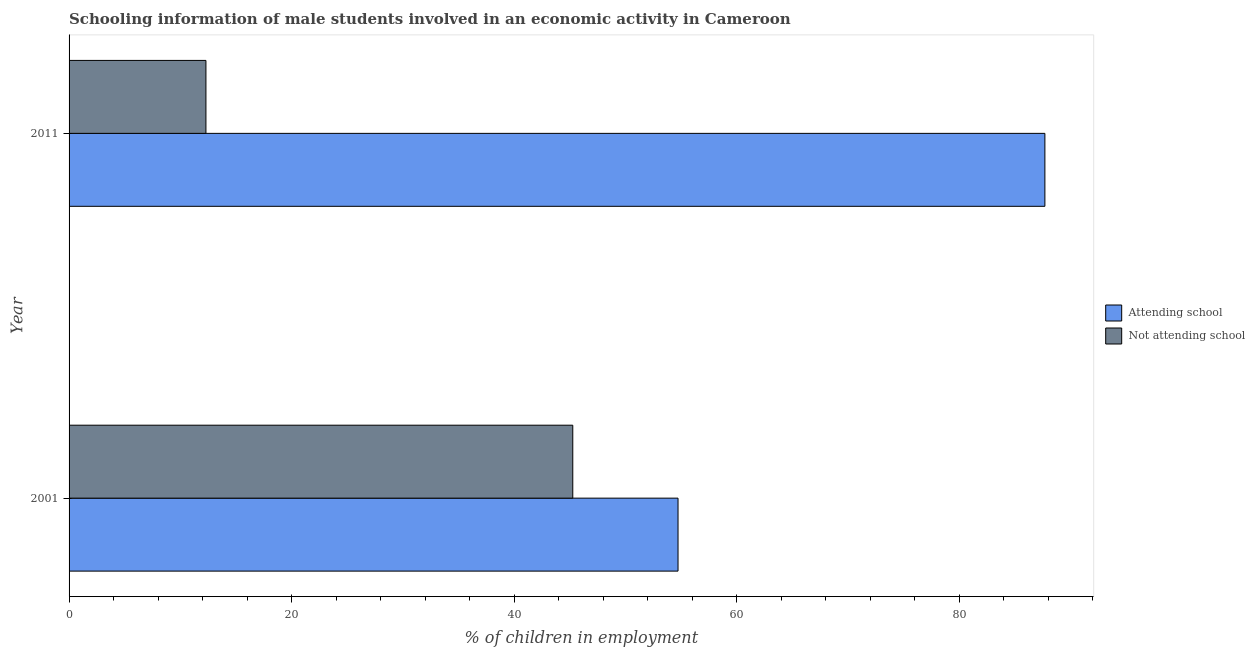How many different coloured bars are there?
Offer a very short reply. 2. Are the number of bars per tick equal to the number of legend labels?
Ensure brevity in your answer.  Yes. How many bars are there on the 1st tick from the top?
Your answer should be compact. 2. How many bars are there on the 2nd tick from the bottom?
Offer a very short reply. 2. What is the label of the 2nd group of bars from the top?
Your answer should be compact. 2001. Across all years, what is the maximum percentage of employed males who are not attending school?
Your answer should be very brief. 45.27. Across all years, what is the minimum percentage of employed males who are not attending school?
Offer a terse response. 12.3. In which year was the percentage of employed males who are attending school maximum?
Provide a short and direct response. 2011. What is the total percentage of employed males who are attending school in the graph?
Offer a terse response. 142.43. What is the difference between the percentage of employed males who are not attending school in 2001 and that in 2011?
Give a very brief answer. 32.97. What is the difference between the percentage of employed males who are attending school in 2011 and the percentage of employed males who are not attending school in 2001?
Give a very brief answer. 42.43. What is the average percentage of employed males who are not attending school per year?
Keep it short and to the point. 28.79. In the year 2001, what is the difference between the percentage of employed males who are not attending school and percentage of employed males who are attending school?
Your answer should be very brief. -9.46. What is the ratio of the percentage of employed males who are not attending school in 2001 to that in 2011?
Give a very brief answer. 3.68. Is the percentage of employed males who are attending school in 2001 less than that in 2011?
Your answer should be very brief. Yes. What does the 1st bar from the top in 2001 represents?
Offer a terse response. Not attending school. What does the 1st bar from the bottom in 2011 represents?
Your answer should be compact. Attending school. How many bars are there?
Offer a terse response. 4. Are all the bars in the graph horizontal?
Your answer should be very brief. Yes. How many years are there in the graph?
Your answer should be compact. 2. Does the graph contain any zero values?
Provide a succinct answer. No. How are the legend labels stacked?
Keep it short and to the point. Vertical. What is the title of the graph?
Provide a succinct answer. Schooling information of male students involved in an economic activity in Cameroon. What is the label or title of the X-axis?
Make the answer very short. % of children in employment. What is the % of children in employment in Attending school in 2001?
Keep it short and to the point. 54.73. What is the % of children in employment in Not attending school in 2001?
Make the answer very short. 45.27. What is the % of children in employment in Attending school in 2011?
Make the answer very short. 87.7. Across all years, what is the maximum % of children in employment in Attending school?
Ensure brevity in your answer.  87.7. Across all years, what is the maximum % of children in employment of Not attending school?
Your answer should be compact. 45.27. Across all years, what is the minimum % of children in employment of Attending school?
Your answer should be compact. 54.73. What is the total % of children in employment in Attending school in the graph?
Offer a terse response. 142.43. What is the total % of children in employment of Not attending school in the graph?
Make the answer very short. 57.57. What is the difference between the % of children in employment in Attending school in 2001 and that in 2011?
Offer a terse response. -32.97. What is the difference between the % of children in employment in Not attending school in 2001 and that in 2011?
Your answer should be compact. 32.97. What is the difference between the % of children in employment of Attending school in 2001 and the % of children in employment of Not attending school in 2011?
Ensure brevity in your answer.  42.43. What is the average % of children in employment in Attending school per year?
Keep it short and to the point. 71.21. What is the average % of children in employment in Not attending school per year?
Make the answer very short. 28.79. In the year 2001, what is the difference between the % of children in employment in Attending school and % of children in employment in Not attending school?
Your answer should be compact. 9.46. In the year 2011, what is the difference between the % of children in employment in Attending school and % of children in employment in Not attending school?
Provide a succinct answer. 75.4. What is the ratio of the % of children in employment of Attending school in 2001 to that in 2011?
Keep it short and to the point. 0.62. What is the ratio of the % of children in employment in Not attending school in 2001 to that in 2011?
Make the answer very short. 3.68. What is the difference between the highest and the second highest % of children in employment in Attending school?
Ensure brevity in your answer.  32.97. What is the difference between the highest and the second highest % of children in employment of Not attending school?
Offer a very short reply. 32.97. What is the difference between the highest and the lowest % of children in employment of Attending school?
Provide a succinct answer. 32.97. What is the difference between the highest and the lowest % of children in employment in Not attending school?
Provide a short and direct response. 32.97. 